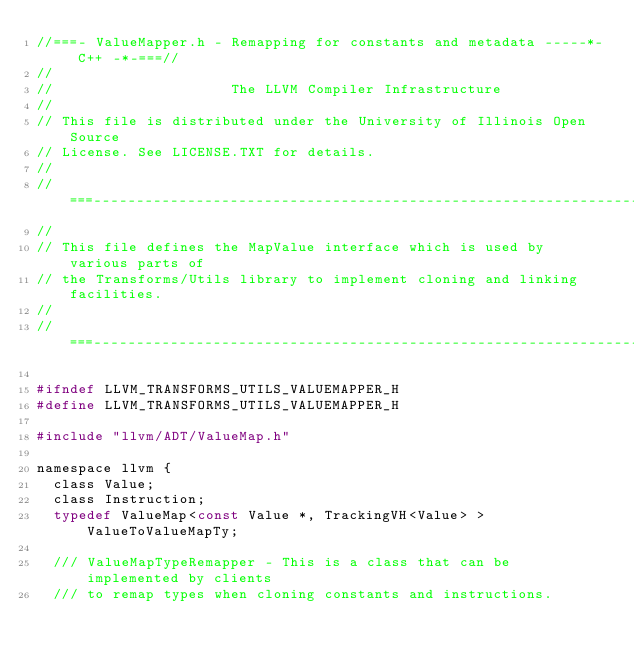Convert code to text. <code><loc_0><loc_0><loc_500><loc_500><_C_>//===- ValueMapper.h - Remapping for constants and metadata -----*- C++ -*-===//
//
//                     The LLVM Compiler Infrastructure
//
// This file is distributed under the University of Illinois Open Source
// License. See LICENSE.TXT for details.
//
//===----------------------------------------------------------------------===//
//
// This file defines the MapValue interface which is used by various parts of
// the Transforms/Utils library to implement cloning and linking facilities.
//
//===----------------------------------------------------------------------===//

#ifndef LLVM_TRANSFORMS_UTILS_VALUEMAPPER_H
#define LLVM_TRANSFORMS_UTILS_VALUEMAPPER_H

#include "llvm/ADT/ValueMap.h"

namespace llvm {
  class Value;
  class Instruction;
  typedef ValueMap<const Value *, TrackingVH<Value> > ValueToValueMapTy;

  /// ValueMapTypeRemapper - This is a class that can be implemented by clients
  /// to remap types when cloning constants and instructions.</code> 